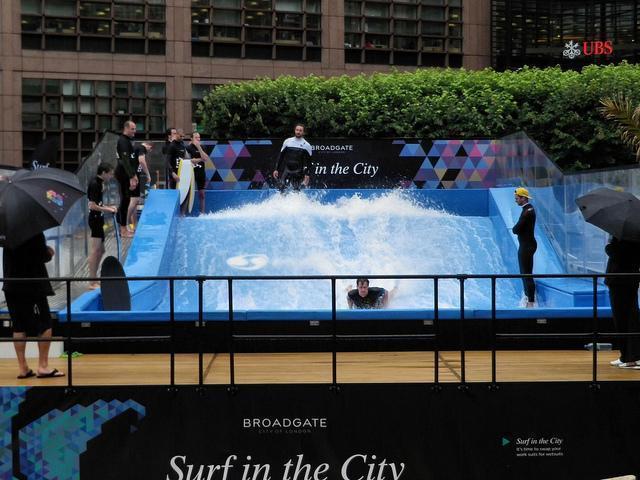What type of area is this event taking place at?
Answer the question by selecting the correct answer among the 4 following choices and explain your choice with a short sentence. The answer should be formatted with the following format: `Answer: choice
Rationale: rationale.`
Options: Rural, city, residential, country. Answer: city.
Rationale: You can see the building in the background that would suggest what area this is in. 